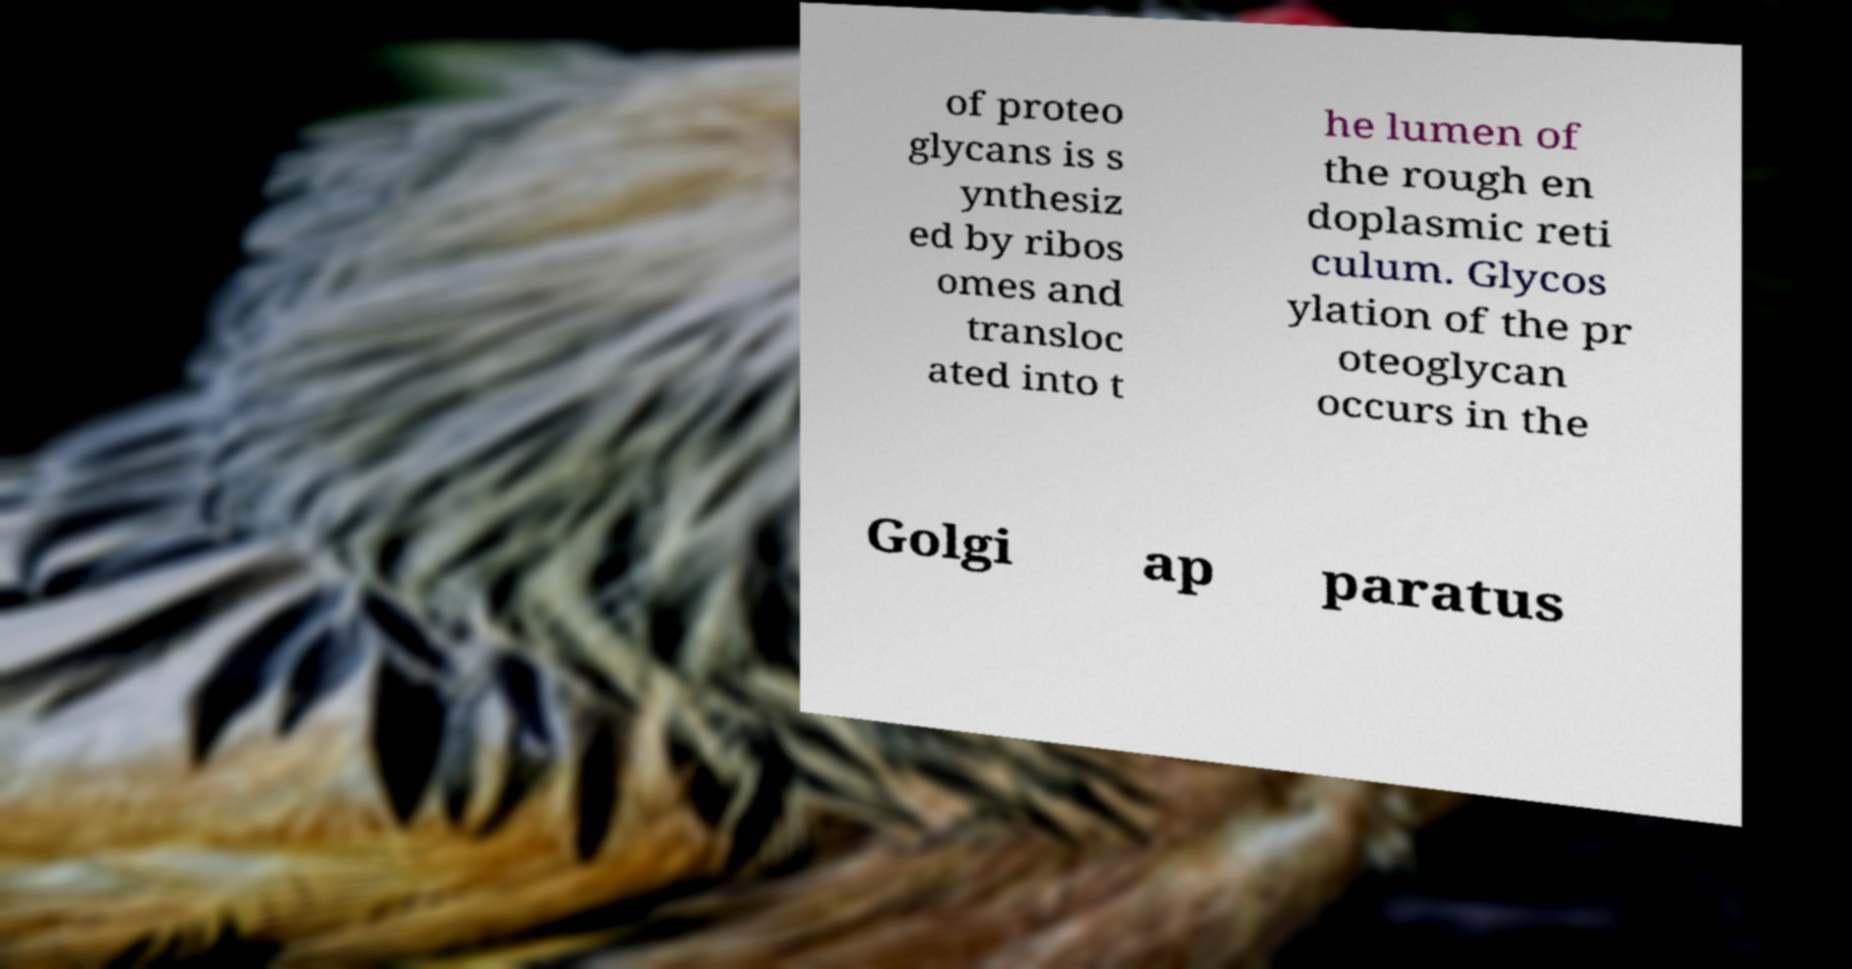Could you assist in decoding the text presented in this image and type it out clearly? of proteo glycans is s ynthesiz ed by ribos omes and transloc ated into t he lumen of the rough en doplasmic reti culum. Glycos ylation of the pr oteoglycan occurs in the Golgi ap paratus 